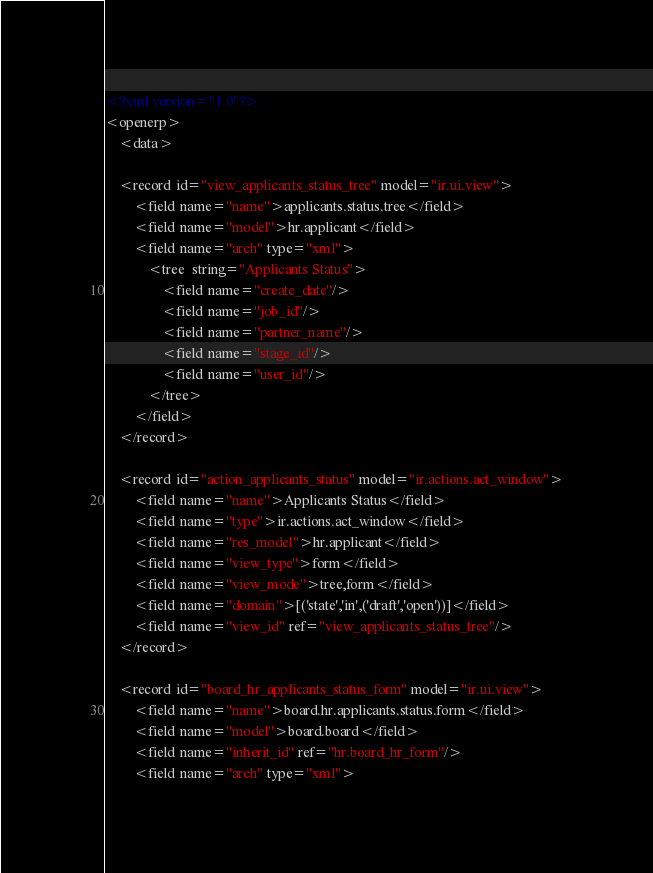Convert code to text. <code><loc_0><loc_0><loc_500><loc_500><_XML_><?xml version="1.0"?>
<openerp>
    <data>

    <record id="view_applicants_status_tree" model="ir.ui.view">
        <field name="name">applicants.status.tree</field>
        <field name="model">hr.applicant</field>
        <field name="arch" type="xml">
            <tree  string="Applicants Status">
                <field name="create_date"/>
                <field name="job_id"/>
                <field name="partner_name"/>
                <field name="stage_id"/>
                <field name="user_id"/>
            </tree>
        </field>
    </record>

    <record id="action_applicants_status" model="ir.actions.act_window">
        <field name="name">Applicants Status</field>
        <field name="type">ir.actions.act_window</field>
        <field name="res_model">hr.applicant</field>
        <field name="view_type">form</field>
        <field name="view_mode">tree,form</field>
        <field name="domain">[('state','in',('draft','open'))]</field>
        <field name="view_id" ref="view_applicants_status_tree"/>
    </record>

    <record id="board_hr_applicants_status_form" model="ir.ui.view">
        <field name="name">board.hr.applicants.status.form</field>
        <field name="model">board.board</field>
        <field name="inherit_id" ref="hr.board_hr_form"/>
        <field name="arch" type="xml"></code> 